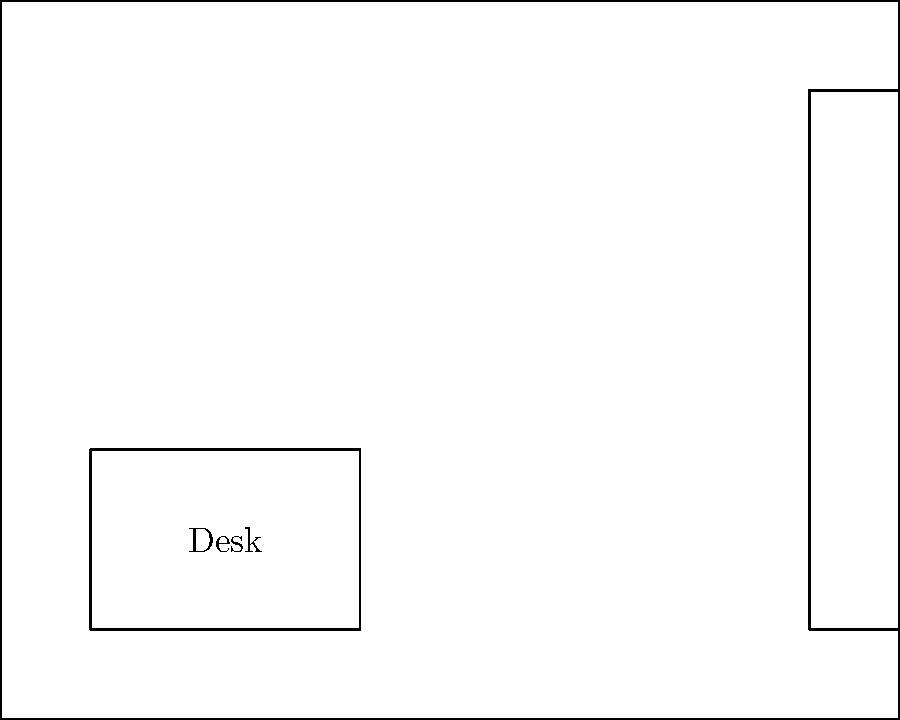In a classic film noir detective's office, four crucial pieces of evidence (A, B, C, and D) are hidden. The detective stands in the center of the room, pondering his next move. If he were to collect the evidence in the most efficient order, minimizing his total distance traveled and ending at the window for a dramatic final scene, what would be the correct sequence of collection? To solve this spatial reasoning problem, we need to analyze the layout and determine the most efficient path for the detective:

1. The detective starts in the center of the room.
2. Clue A is on the desk, closest to the detective's starting position.
3. From A, the next closest clue is C in the filing cabinet.
4. After C, clue B on the bookshelf is the nearest.
5. Finally, clue D at the window is last, which conveniently allows for the dramatic final scene.

The path would look like this:
Detective (start) → A (desk) → C (cabinet) → B (bookshelf) → D (window)

This route minimizes the total distance traveled while collecting all clues and ending at the window for the dramatic conclusion, fitting perfectly with the film noir aesthetic and the persona's dislike for artificial drama.
Answer: A, C, B, D 